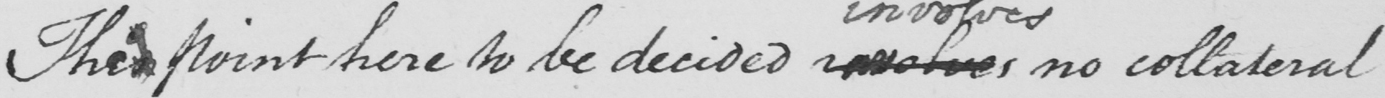What text is written in this handwritten line? Thise point here to be decided involves no collateral 